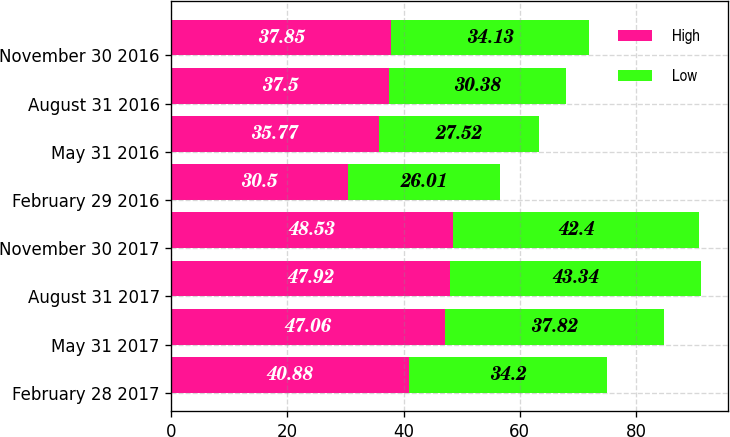Convert chart to OTSL. <chart><loc_0><loc_0><loc_500><loc_500><stacked_bar_chart><ecel><fcel>February 28 2017<fcel>May 31 2017<fcel>August 31 2017<fcel>November 30 2017<fcel>February 29 2016<fcel>May 31 2016<fcel>August 31 2016<fcel>November 30 2016<nl><fcel>High<fcel>40.88<fcel>47.06<fcel>47.92<fcel>48.53<fcel>30.5<fcel>35.77<fcel>37.5<fcel>37.85<nl><fcel>Low<fcel>34.2<fcel>37.82<fcel>43.34<fcel>42.4<fcel>26.01<fcel>27.52<fcel>30.38<fcel>34.13<nl></chart> 